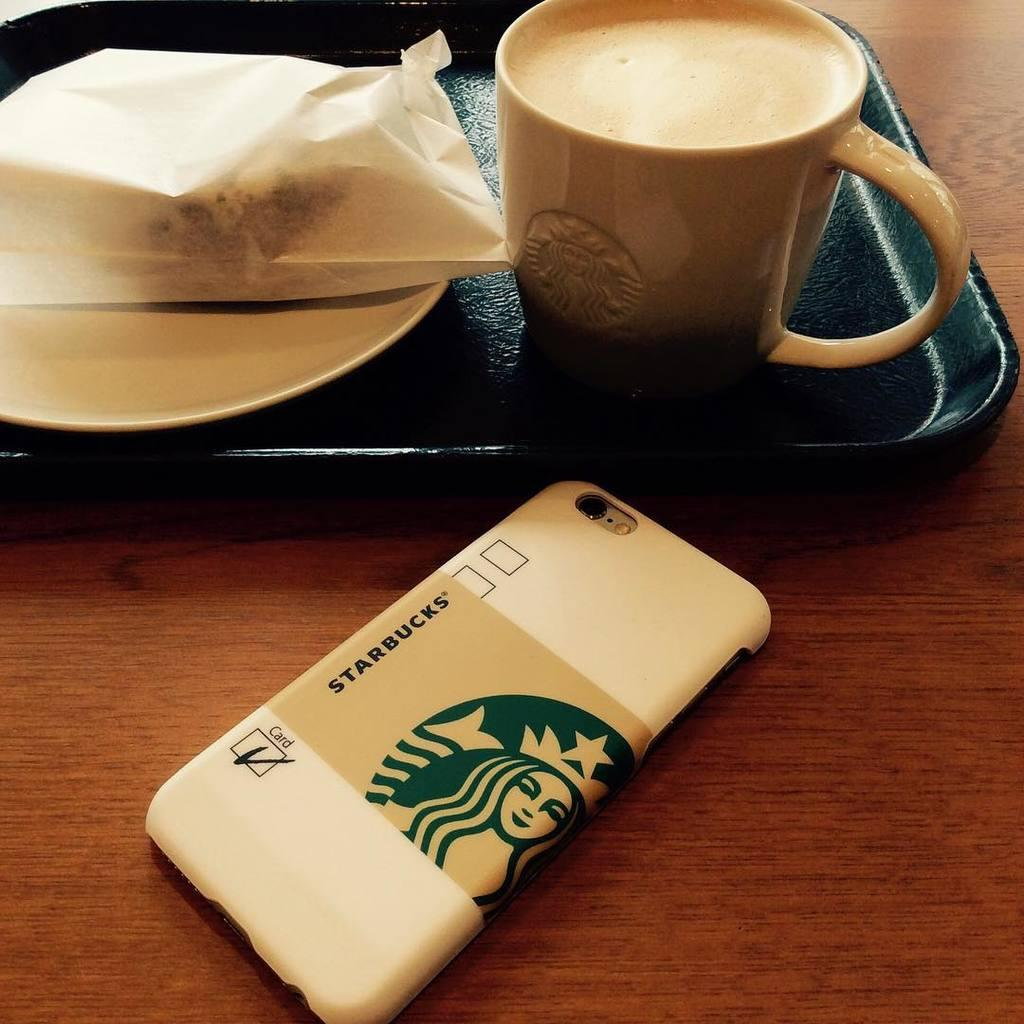What is the main subject of the image? The main subject of the image is a coffee. What is the coffee placed on? The coffee is on a black tray. What else is present on the table with the coffee? There is a mobile beside the coffee. What type of table is the coffee and mobile placed on? Both the coffee and the mobile are on a wooden table. What time of day is the kiss taking place in the image? There is no kiss present in the image. Can you tell me the birth date of the baby in the image? There is no baby present in the image. 